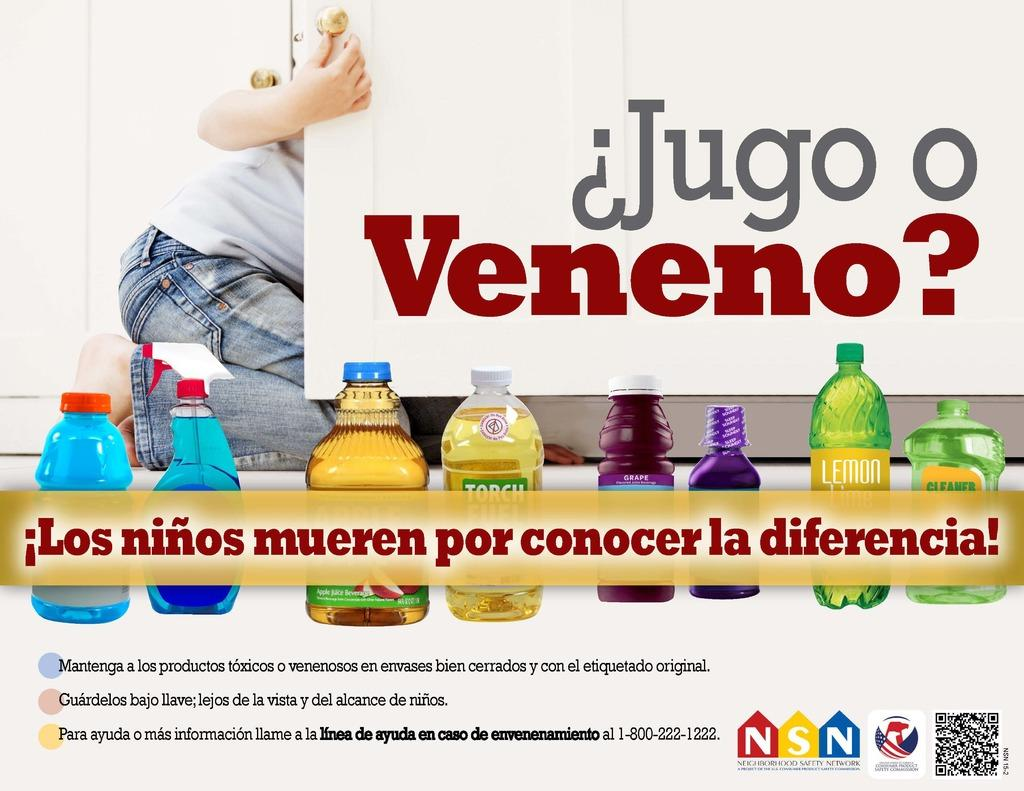<image>
Create a compact narrative representing the image presented. A sign asks the question "Jugo o Veneno?" 